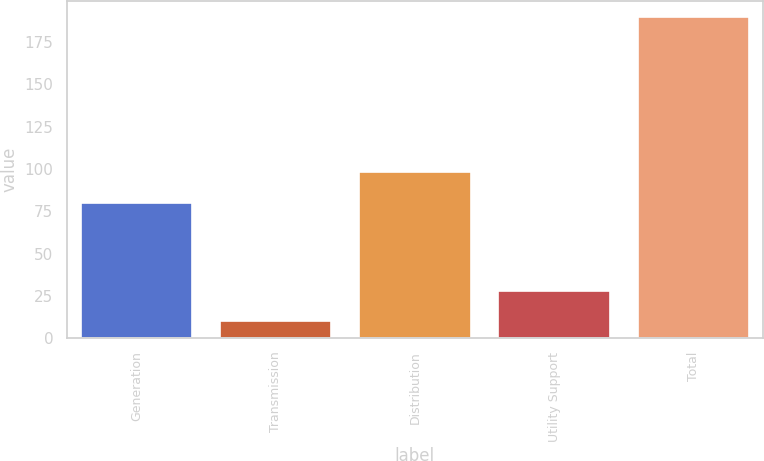Convert chart to OTSL. <chart><loc_0><loc_0><loc_500><loc_500><bar_chart><fcel>Generation<fcel>Transmission<fcel>Distribution<fcel>Utility Support<fcel>Total<nl><fcel>80<fcel>10<fcel>98<fcel>28<fcel>190<nl></chart> 